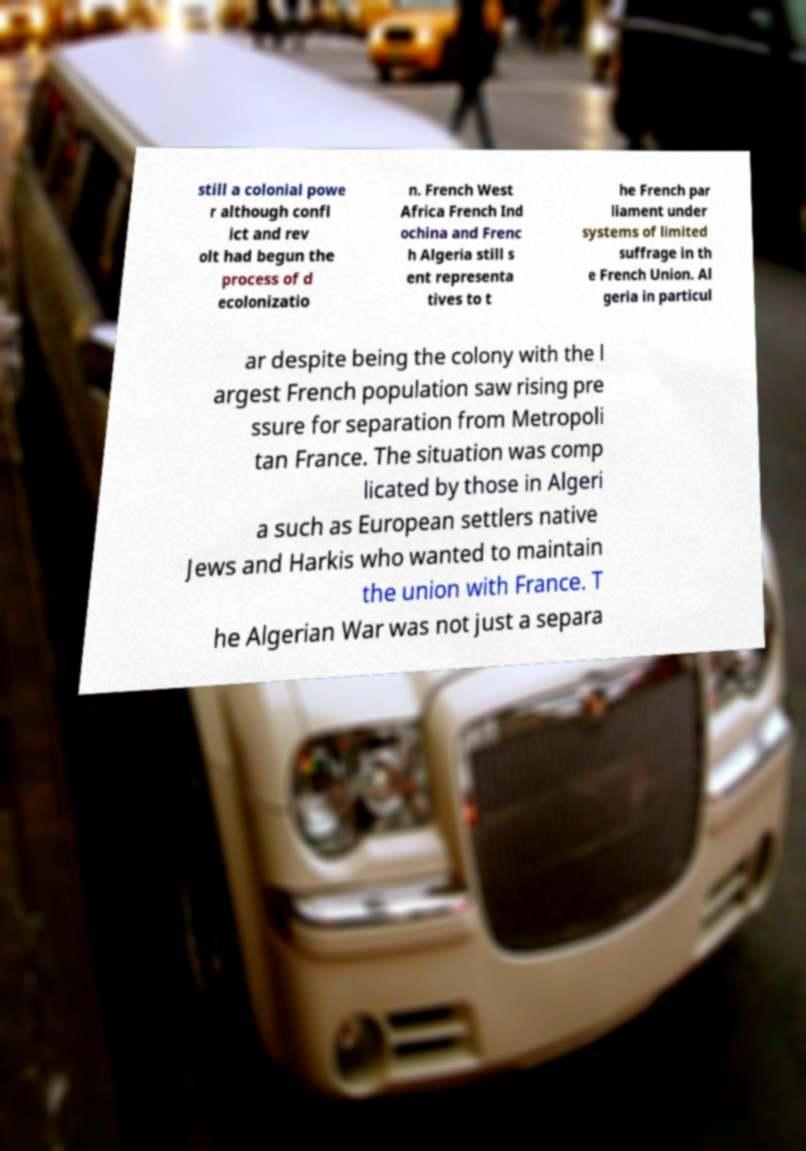Can you read and provide the text displayed in the image?This photo seems to have some interesting text. Can you extract and type it out for me? still a colonial powe r although confl ict and rev olt had begun the process of d ecolonizatio n. French West Africa French Ind ochina and Frenc h Algeria still s ent representa tives to t he French par liament under systems of limited suffrage in th e French Union. Al geria in particul ar despite being the colony with the l argest French population saw rising pre ssure for separation from Metropoli tan France. The situation was comp licated by those in Algeri a such as European settlers native Jews and Harkis who wanted to maintain the union with France. T he Algerian War was not just a separa 